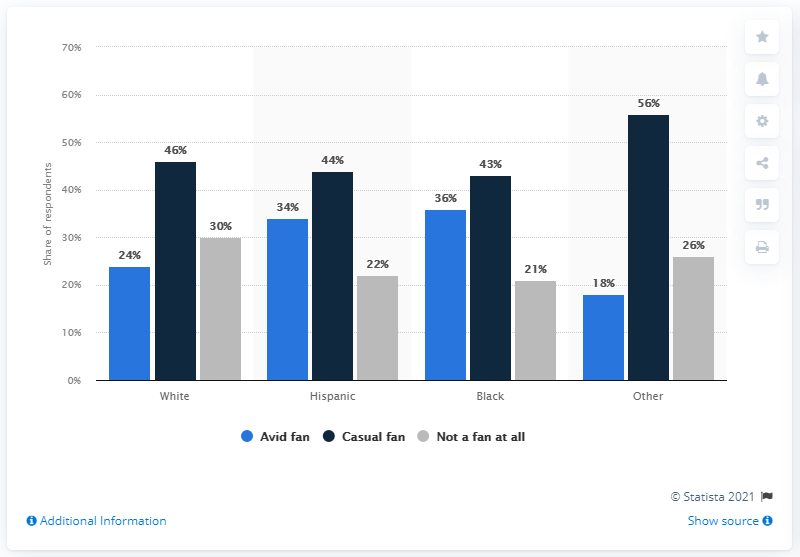Outline some significant characteristics in this image. The difference between the highest black casual fan and the lowest is 13. According to the survey, the group with the highest percentage of respondents is "Other. There are approximately 44 million sports fans in the United States. 